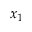Convert formula to latex. <formula><loc_0><loc_0><loc_500><loc_500>x _ { 1 }</formula> 